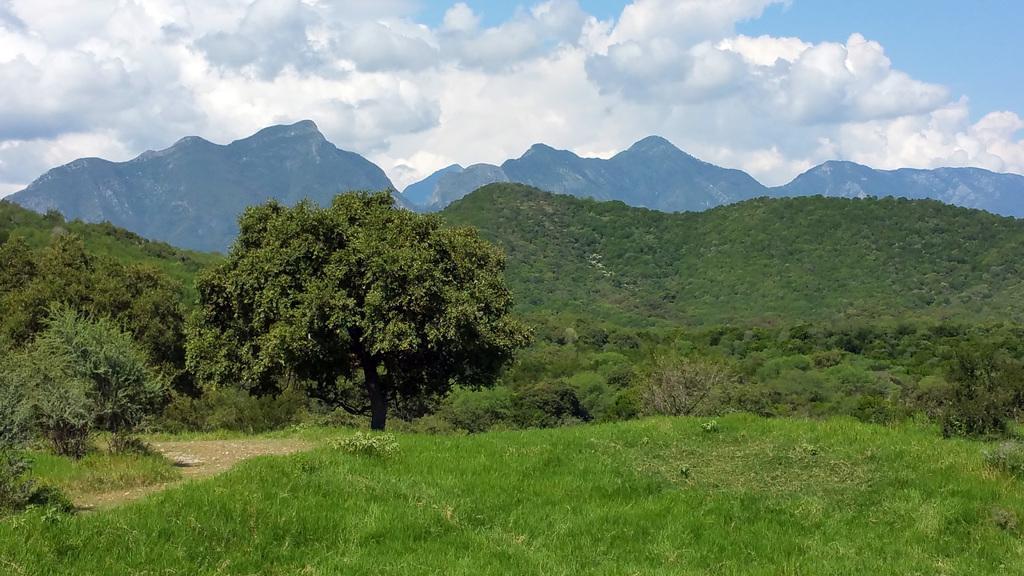In one or two sentences, can you explain what this image depicts? At the bottom of the image there is grass on the ground. And also there are small plants and trees in the image. Behind them there are hills. At the top of the image there is sky with clouds. 